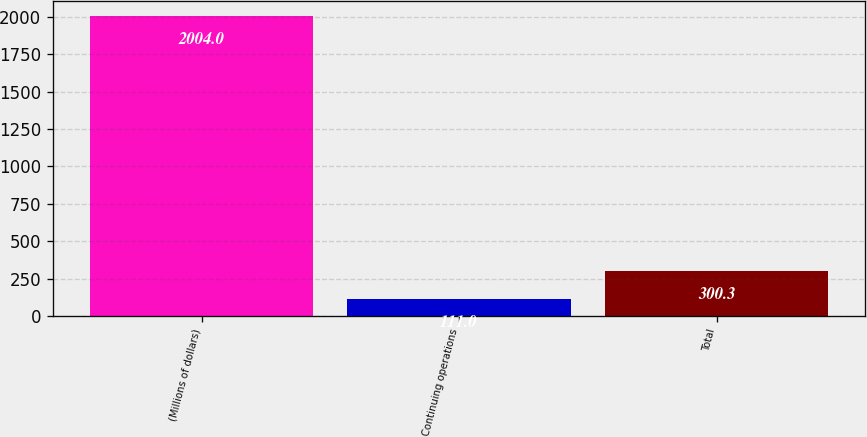Convert chart to OTSL. <chart><loc_0><loc_0><loc_500><loc_500><bar_chart><fcel>(Millions of dollars)<fcel>Continuing operations<fcel>Total<nl><fcel>2004<fcel>111<fcel>300.3<nl></chart> 